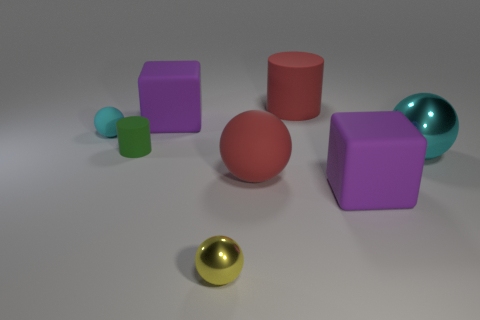Does the big shiny thing have the same color as the small matte sphere?
Give a very brief answer. Yes. The ball that is made of the same material as the yellow object is what color?
Keep it short and to the point. Cyan. Does the purple thing that is right of the tiny yellow metal ball have the same material as the cyan ball that is right of the small green matte cylinder?
Give a very brief answer. No. Are there any metal objects that have the same size as the yellow sphere?
Provide a succinct answer. No. There is a shiny sphere on the left side of the cylinder that is right of the green thing; what is its size?
Ensure brevity in your answer.  Small. How many objects are the same color as the tiny matte sphere?
Provide a short and direct response. 1. There is a red matte object that is in front of the small cyan object that is to the left of the tiny yellow object; what shape is it?
Your response must be concise. Sphere. How many other large spheres have the same material as the yellow sphere?
Your response must be concise. 1. There is a purple thing to the right of the tiny yellow thing; what is its material?
Your answer should be very brief. Rubber. What shape is the big purple object that is to the right of the cylinder that is behind the tiny thing behind the green cylinder?
Ensure brevity in your answer.  Cube. 